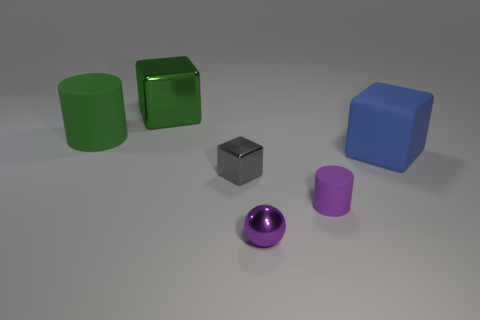Subtract all big matte blocks. How many blocks are left? 2 Subtract 1 cubes. How many cubes are left? 2 Add 1 big metal objects. How many objects exist? 7 Subtract all brown cubes. Subtract all green cylinders. How many cubes are left? 3 Subtract all green matte things. Subtract all small matte objects. How many objects are left? 4 Add 1 green shiny objects. How many green shiny objects are left? 2 Add 4 purple rubber objects. How many purple rubber objects exist? 5 Subtract 1 blue blocks. How many objects are left? 5 Subtract all cylinders. How many objects are left? 4 